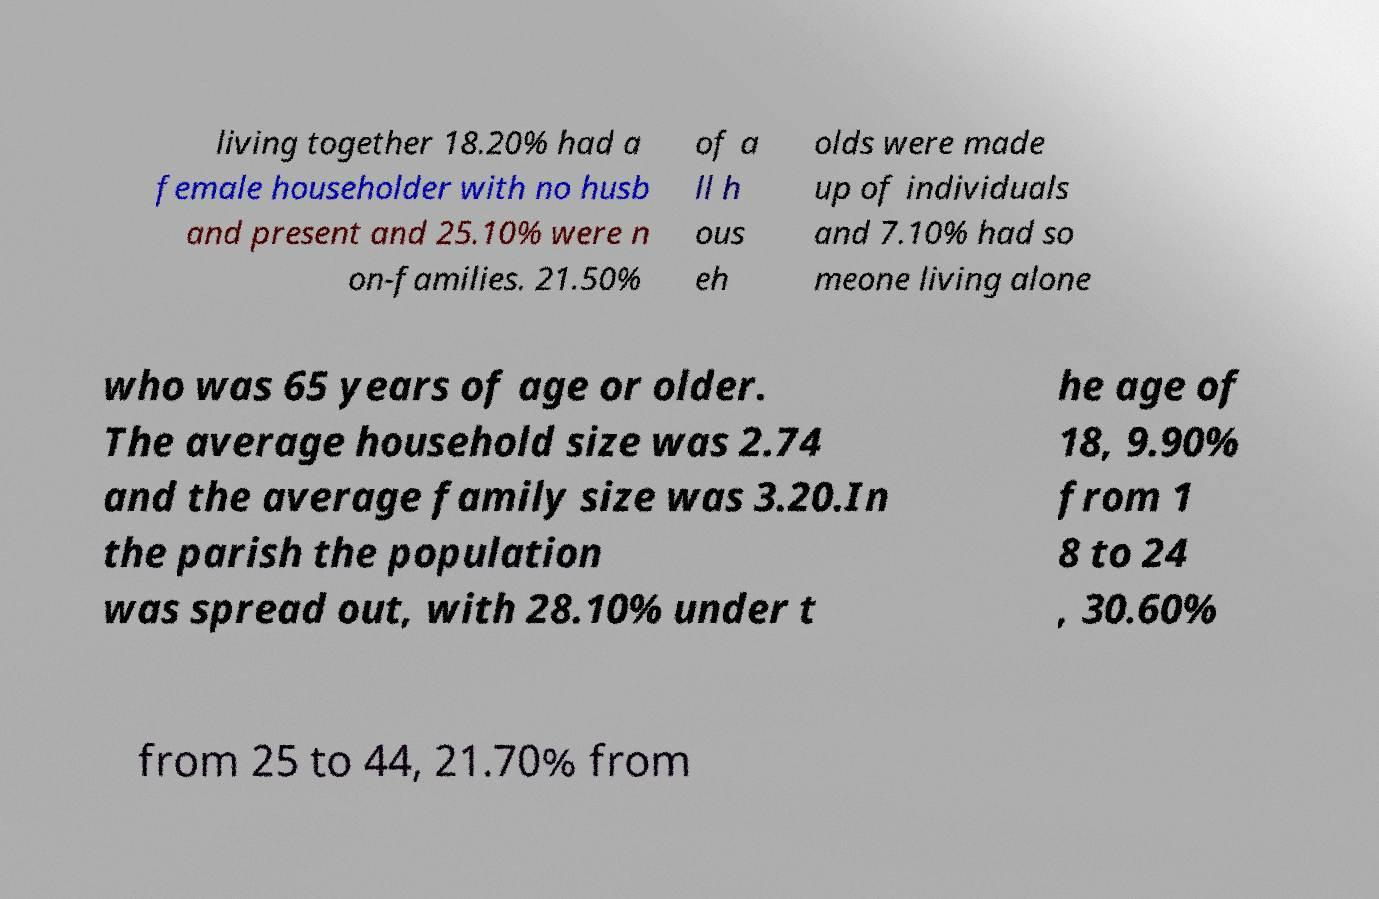I need the written content from this picture converted into text. Can you do that? living together 18.20% had a female householder with no husb and present and 25.10% were n on-families. 21.50% of a ll h ous eh olds were made up of individuals and 7.10% had so meone living alone who was 65 years of age or older. The average household size was 2.74 and the average family size was 3.20.In the parish the population was spread out, with 28.10% under t he age of 18, 9.90% from 1 8 to 24 , 30.60% from 25 to 44, 21.70% from 